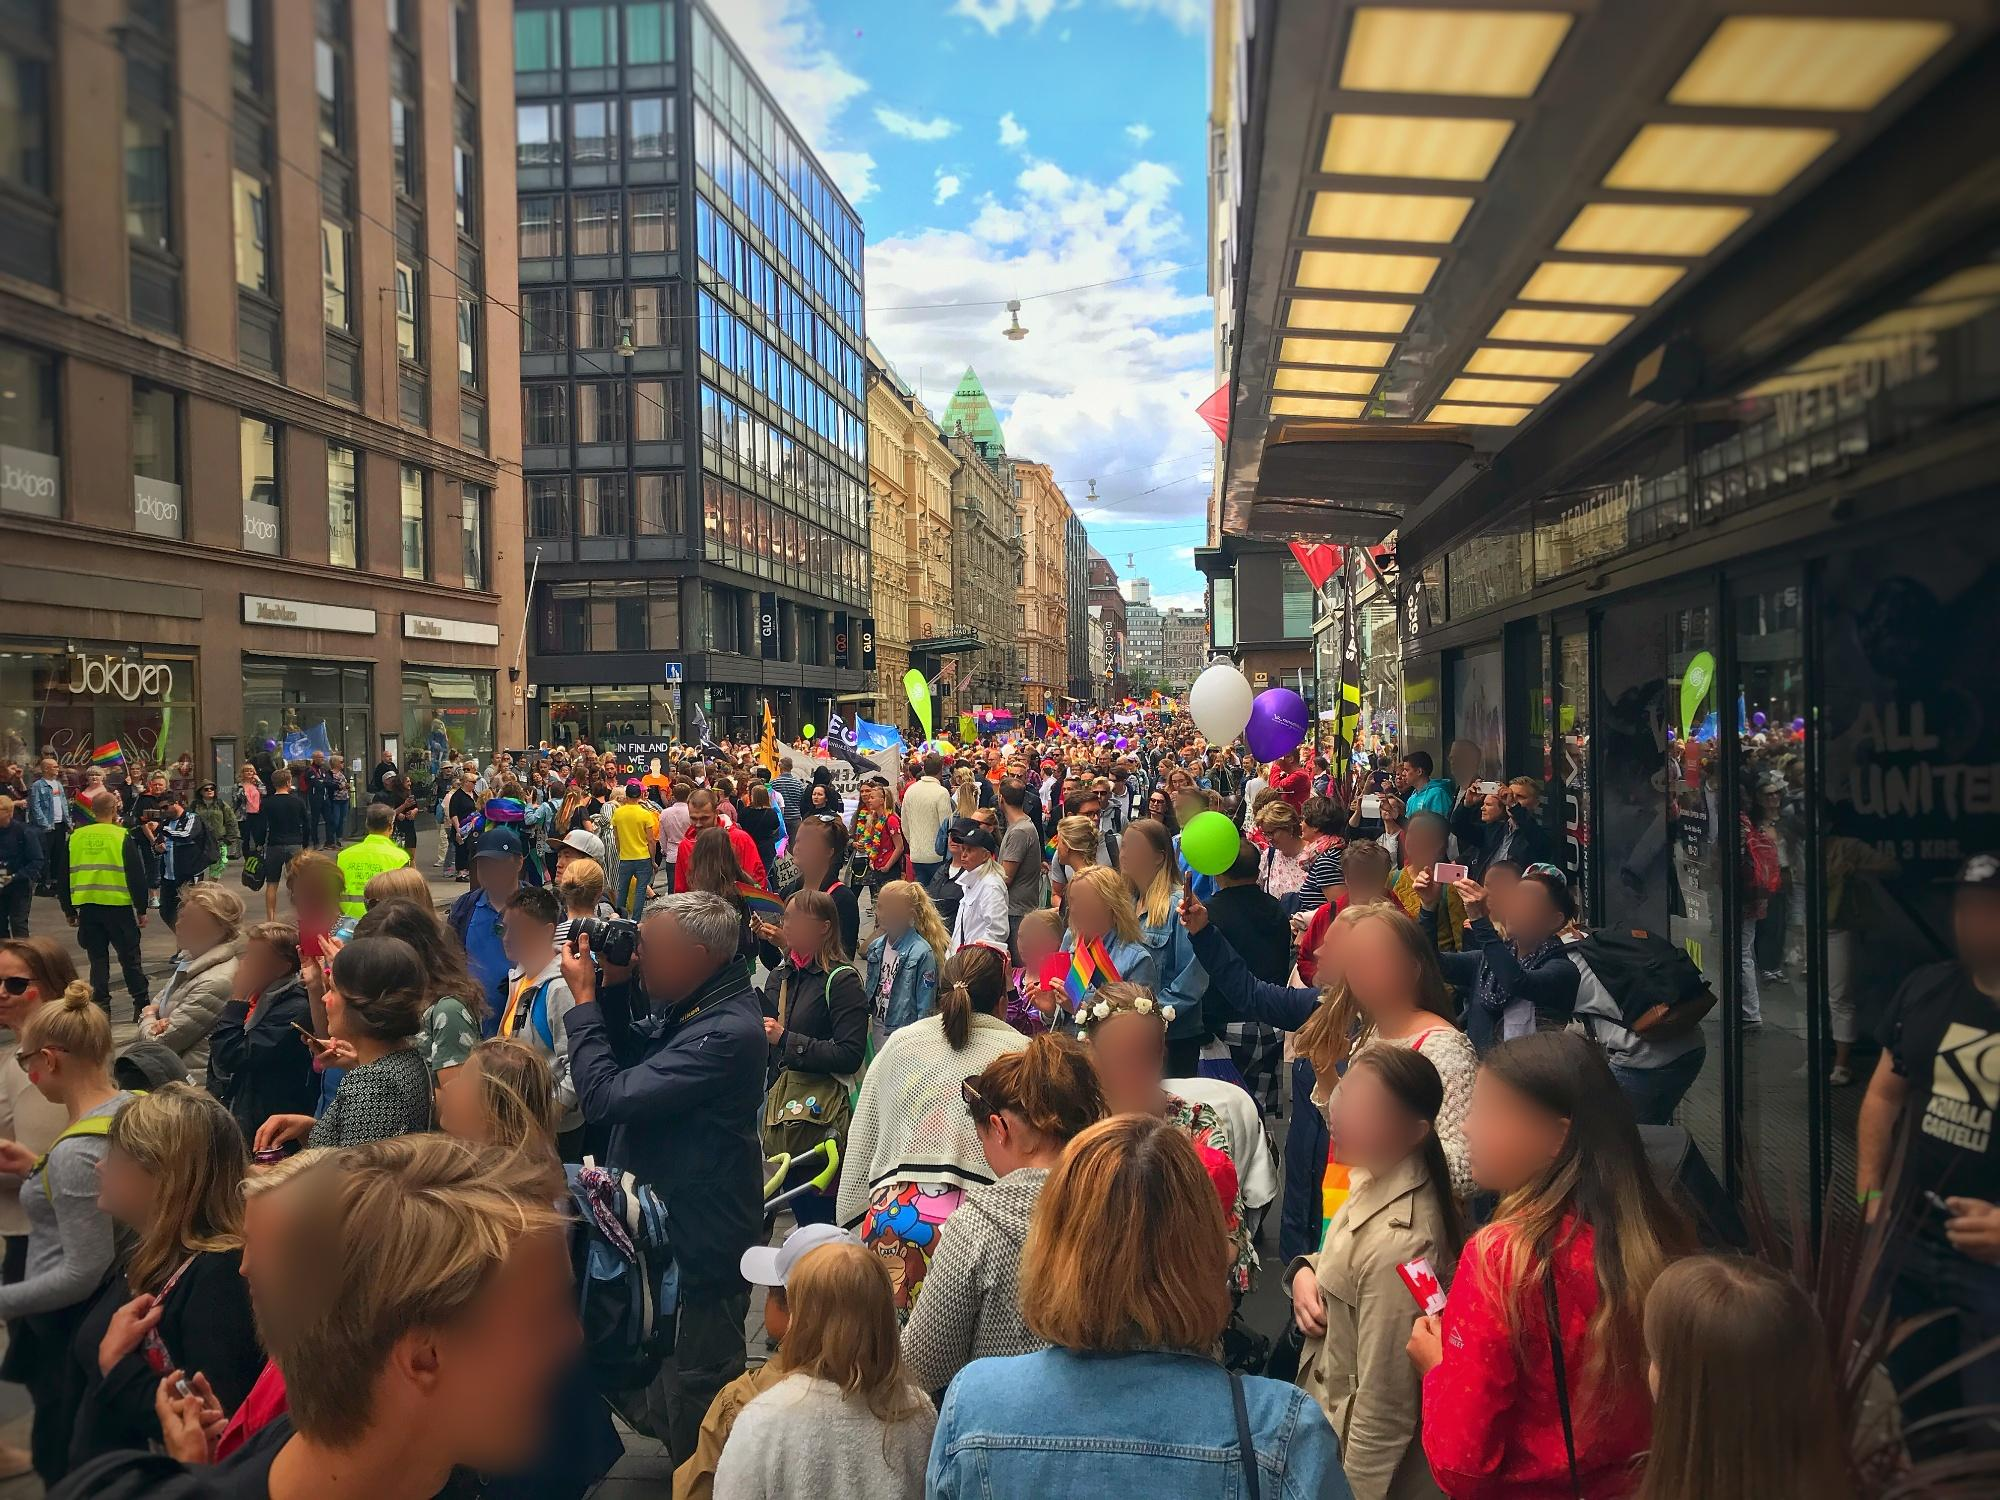Can you describe the emotions you think people in the image might be experiencing? The image conveys a wide range of emotions stemming from the vibrant parade. There is a palpable sense of joy and excitement in the atmosphere. Many people appear to be delighted, smiling broadly as they hold colorful balloons and wave flags. Parents and children alike seem to be enjoying the event, with many taking photos to capture the moment. The sense of community and collective celebration is strong, and the general mood can be described as festive and joyful. 